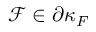Convert formula to latex. <formula><loc_0><loc_0><loc_500><loc_500>\mathcal { F } \in \partial \kappa _ { F }</formula> 